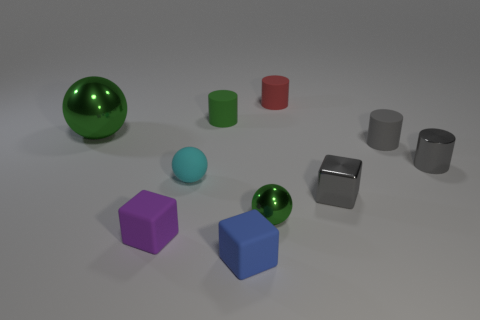How many metal cylinders are the same size as the cyan rubber sphere?
Ensure brevity in your answer.  1. There is a thing that is on the right side of the gray matte cylinder; is its color the same as the block that is on the right side of the small blue cube?
Give a very brief answer. Yes. There is a small purple matte thing; are there any tiny matte blocks to the right of it?
Make the answer very short. Yes. What is the color of the object that is both on the left side of the small cyan thing and to the right of the big green metal thing?
Keep it short and to the point. Purple. Is there a matte thing of the same color as the metal cube?
Your answer should be very brief. Yes. Does the green ball to the right of the tiny purple cube have the same material as the green sphere that is behind the tiny gray shiny cube?
Keep it short and to the point. Yes. There is a green ball on the left side of the tiny purple cube; how big is it?
Give a very brief answer. Large. What is the size of the green sphere behind the ball on the right side of the blue block on the left side of the tiny red cylinder?
Your answer should be very brief. Large. Is there a object made of the same material as the small blue block?
Offer a very short reply. Yes. What shape is the tiny purple rubber thing?
Ensure brevity in your answer.  Cube. 